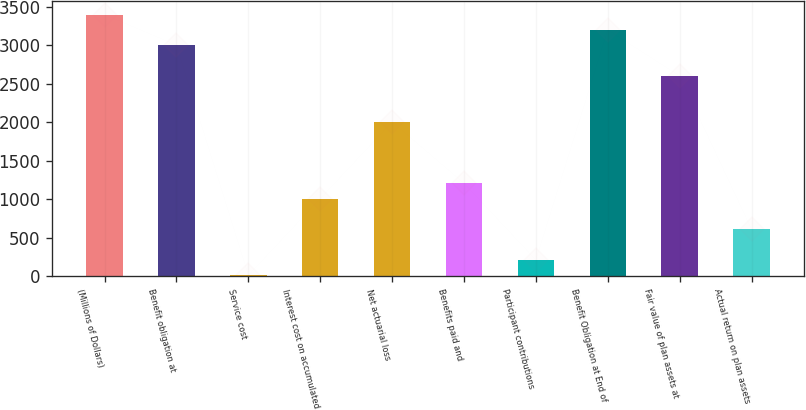Convert chart to OTSL. <chart><loc_0><loc_0><loc_500><loc_500><bar_chart><fcel>(Millions of Dollars)<fcel>Benefit obligation at<fcel>Service cost<fcel>Interest cost on accumulated<fcel>Net actuarial loss<fcel>Benefits paid and<fcel>Participant contributions<fcel>Benefit Obligation at End of<fcel>Fair value of plan assets at<fcel>Actual return on plan assets<nl><fcel>3401.5<fcel>3002.5<fcel>10<fcel>1007.5<fcel>2005<fcel>1207<fcel>209.5<fcel>3202<fcel>2603.5<fcel>608.5<nl></chart> 